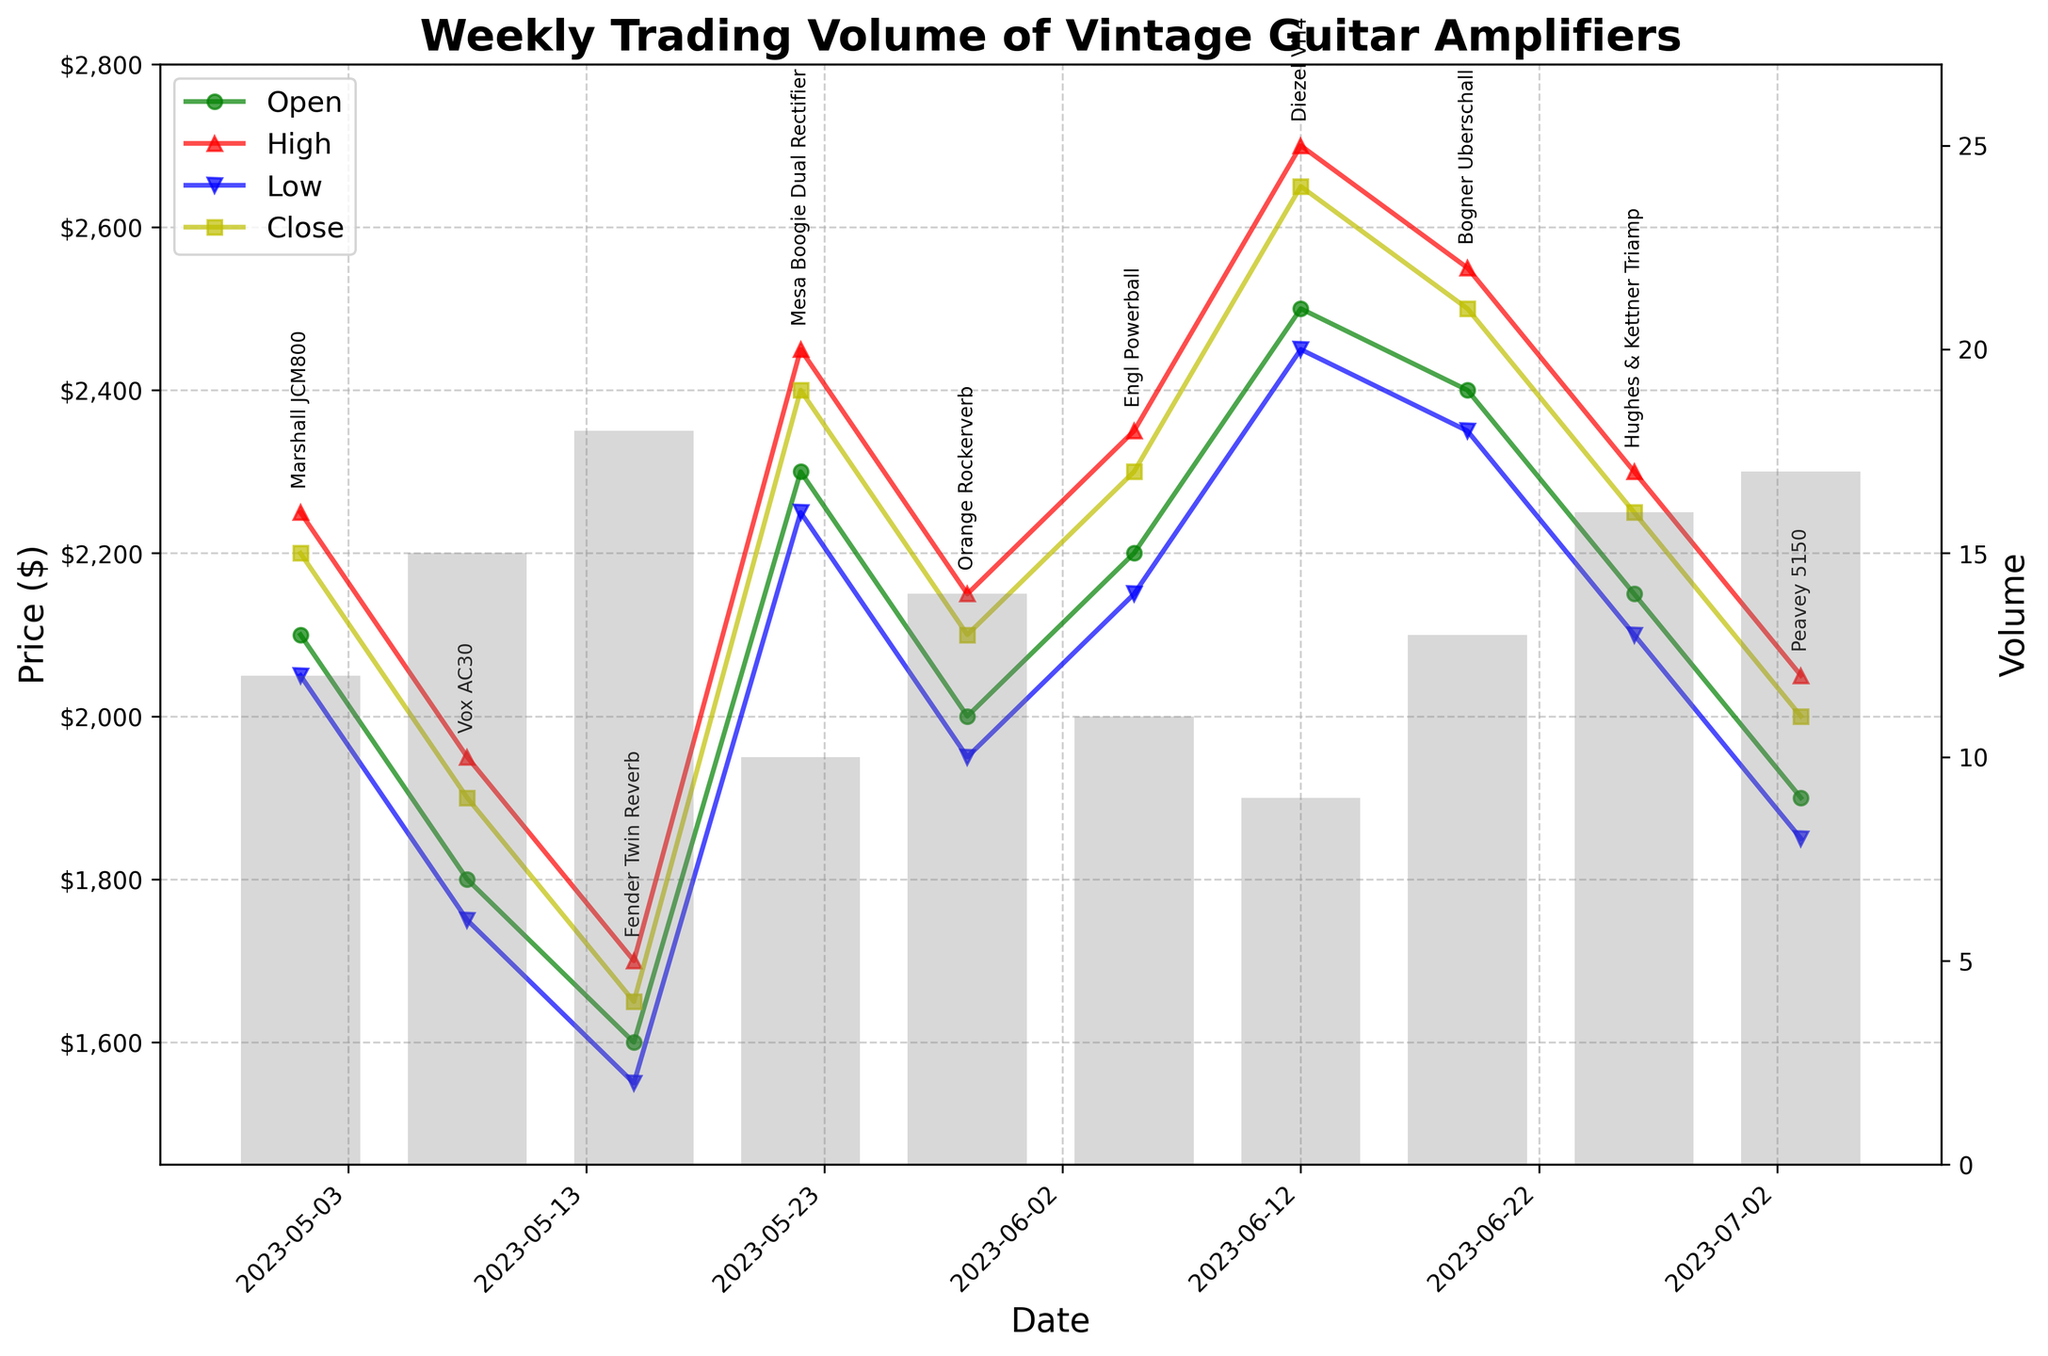What's the title of the chart? The title of the chart is provided at the top of the figure.
Answer: Weekly Trading Volume of Vintage Guitar Amplifiers How many amplifiers are displayed in total? Counting the number of unique amplifier names annotated on the chart will give us the total.
Answer: 10 What was the highest price reached by the Diezel VH4? Locate the Diezel VH4 on the chart and check the highest price point marked by the red triangle.
Answer: $2700 Which amplifier had the highest trading volume? Compare the heights of the gray bars representing volume for each amplifier and identify the tallest one.
Answer: Fender Twin Reverb On which date did the Mesa Boogie Dual Rectifier close at $2400? Locate the Mesa Boogie Dual Rectifier on the chart and check the corresponding date at the bottom of the figure.
Answer: 2023-05-22 Which amplifier opened at the lowest price? Compare the starting points of the green lines (Open price) for all the amplifiers and identify the lowest one.
Answer: Fender Twin Reverb What is the average closing price of the Orange Rockerverb and Hughes & Kettner Triamp? Take the closing prices of the two amplifiers and calculate their average: (2100 + 2250)/2.
Answer: $2175 Which amplifier showed the smallest range in prices during its trading week? Calculate the difference between High and Low prices for each amplifier and find the smallest difference.
Answer: Peavey 5150 Which amplifier saw a drop in price from its opening to its closing? Identify amplifiers where the Close price is lower than the Open price.
Answer: Vox AC30 What is the median trading volume of all the amplifiers? List the trading volumes of all amplifiers in ascending order and find the middle value. For n=10 values, the median is the average of the 5th and 6th values: (12 + 13)/2.
Answer: 12.5 